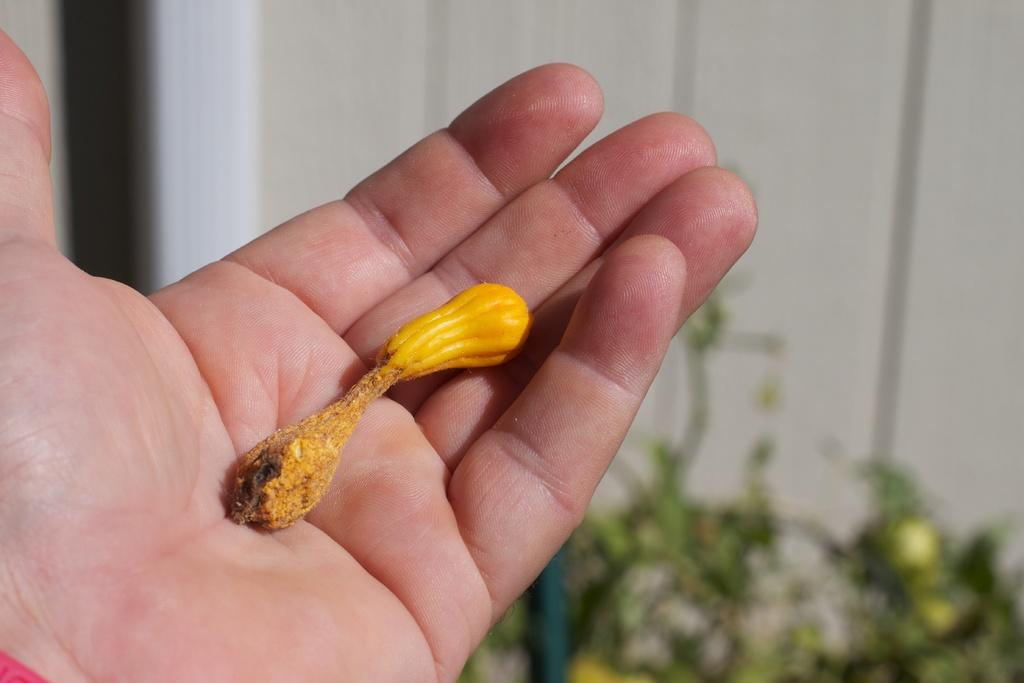What type of flower bud is visible in the image? There is a yellow color flower bud in the image. Who is holding the flower bud in the image? The flower bud is held by a person. Can you describe the background of the image? The background of the image is blurred. What type of nut can be seen on the edge of the flower bud in the image? There is no nut present on the edge of the flower bud in the image. 